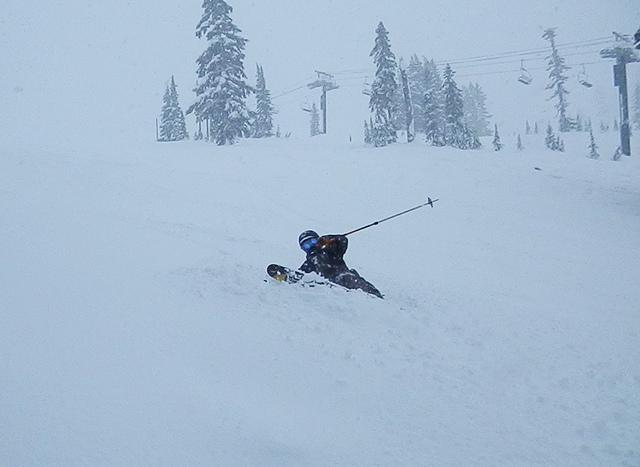How many people are skiing?
Keep it brief. 1. Is it winter?
Give a very brief answer. Yes. What kind of trees are in the picture?
Answer briefly. Pine. 